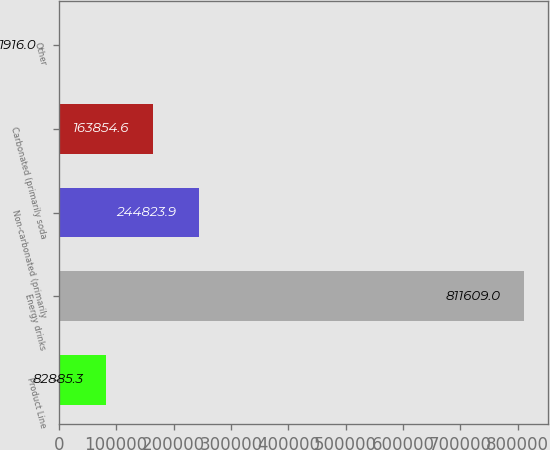Convert chart. <chart><loc_0><loc_0><loc_500><loc_500><bar_chart><fcel>Product Line<fcel>Energy drinks<fcel>Non-carbonated (primarily<fcel>Carbonated (primarily soda<fcel>Other<nl><fcel>82885.3<fcel>811609<fcel>244824<fcel>163855<fcel>1916<nl></chart> 